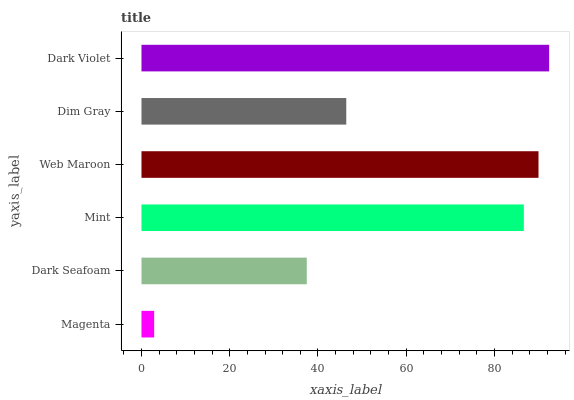Is Magenta the minimum?
Answer yes or no. Yes. Is Dark Violet the maximum?
Answer yes or no. Yes. Is Dark Seafoam the minimum?
Answer yes or no. No. Is Dark Seafoam the maximum?
Answer yes or no. No. Is Dark Seafoam greater than Magenta?
Answer yes or no. Yes. Is Magenta less than Dark Seafoam?
Answer yes or no. Yes. Is Magenta greater than Dark Seafoam?
Answer yes or no. No. Is Dark Seafoam less than Magenta?
Answer yes or no. No. Is Mint the high median?
Answer yes or no. Yes. Is Dim Gray the low median?
Answer yes or no. Yes. Is Dark Seafoam the high median?
Answer yes or no. No. Is Magenta the low median?
Answer yes or no. No. 